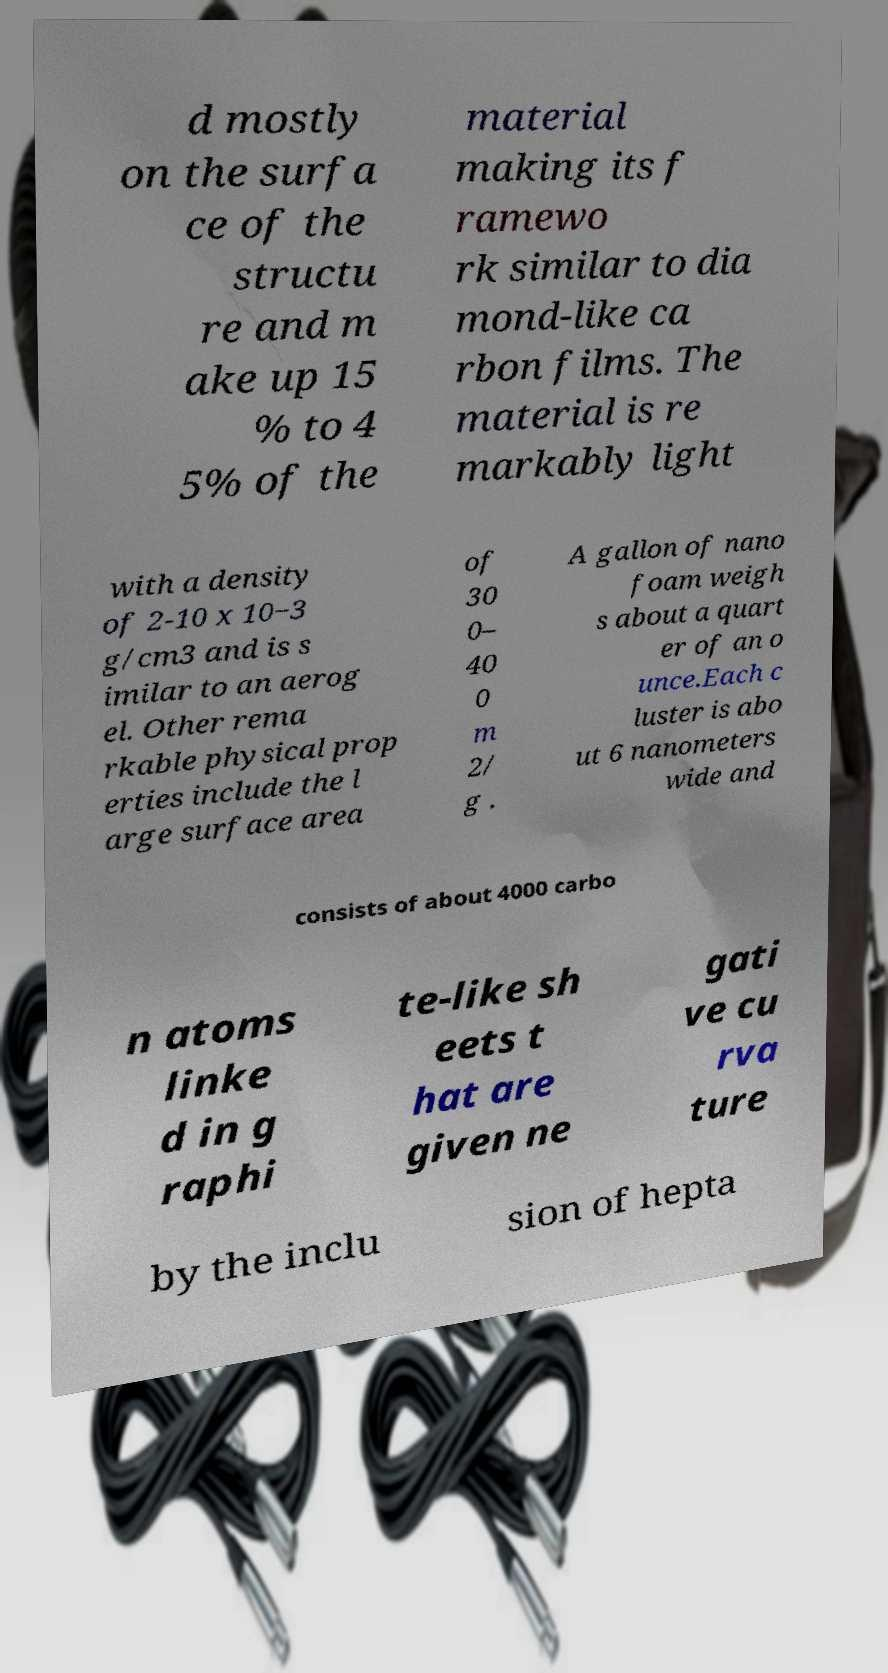I need the written content from this picture converted into text. Can you do that? d mostly on the surfa ce of the structu re and m ake up 15 % to 4 5% of the material making its f ramewo rk similar to dia mond-like ca rbon films. The material is re markably light with a density of 2-10 x 10−3 g/cm3 and is s imilar to an aerog el. Other rema rkable physical prop erties include the l arge surface area of 30 0– 40 0 m 2/ g . A gallon of nano foam weigh s about a quart er of an o unce.Each c luster is abo ut 6 nanometers wide and consists of about 4000 carbo n atoms linke d in g raphi te-like sh eets t hat are given ne gati ve cu rva ture by the inclu sion of hepta 